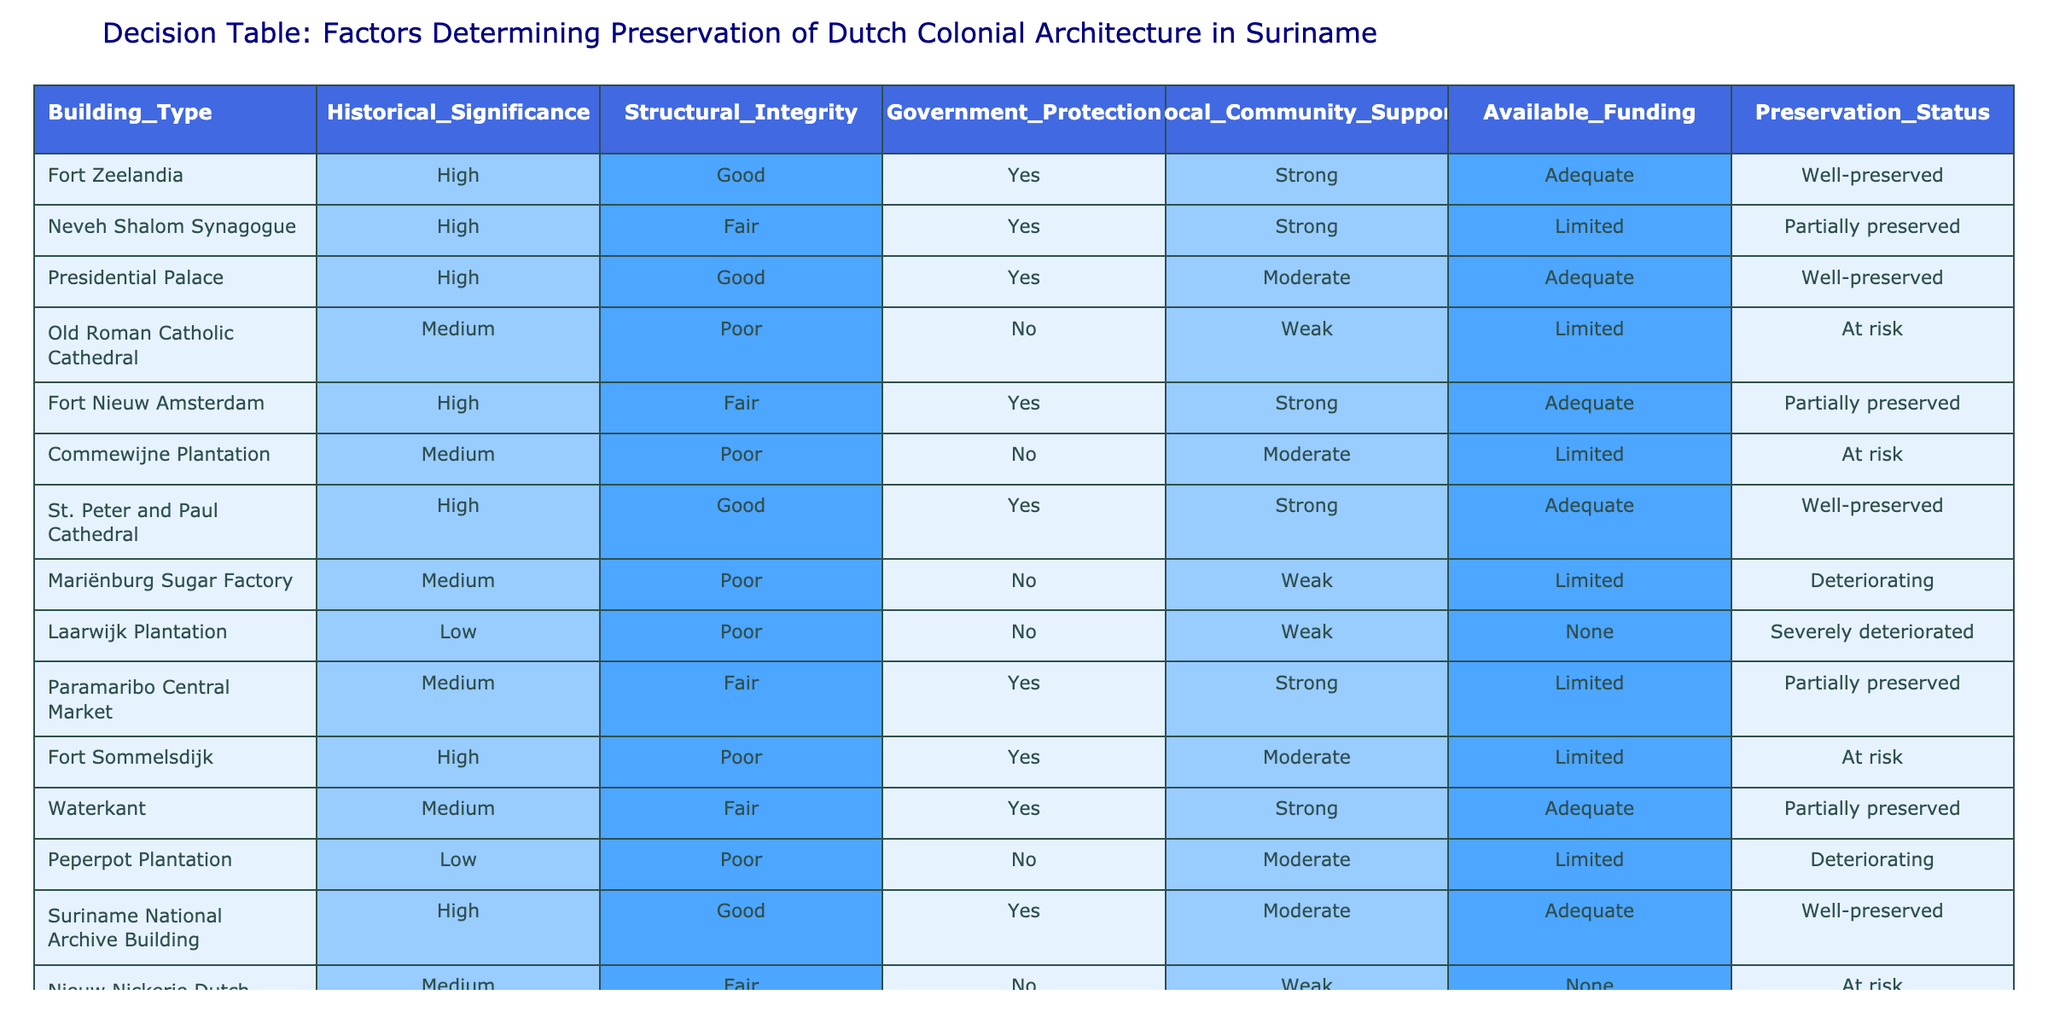What is the preservation status of Fort Zeelandia? The table lists Fort Zeelandia under the "Preservation_Status" column, which shows it is categorized as "Well-preserved."
Answer: Well-preserved How many buildings have government protection? In the table, we look for the "Government_Protection" column where the value is "Yes." Counting the rows with this value, we find there are six buildings with government protection: Fort Zeelandia, Neveh Shalom Synagogue, Presidential Palace, Fort Nieuw Amsterdam, St. Peter and Paul Cathedral, and Suriname National Archive Building.
Answer: 6 What is the average historical significance rating of all buildings listed? The ratings for historical significance are categorized as High, Medium, and Low. Evaluating the table, we count that there are 6 buildings rated High, 5 rated Medium, and 3 rated Low. To compute the average on a scale of 1 to 3 (where High = 3, Medium = 2, Low = 1), we calculate: (6*3 + 5*2 + 3*1) / (6 + 5 + 3) = (18 + 10 + 3) / 14 = 31 / 14 = 2.21. Rounding gives an average significance of 2.2.
Answer: 2.2 Does the Mariënburg Sugar Factory have local community support? Referring to the "Local_Community_Support" column for the Mariënburg Sugar Factory shows "Weak." Therefore, it does not have strong local community backing.
Answer: No What is the total number of buildings at risk of deterioration? We examine the "Preservation_Status" column for the term "At risk." The buildings at risk include the Old Roman Catholic Cathedral, Commewijne Plantation, Fort Sommelsdijk, and Nieuw Nickerie Dutch Reformed Church, totaling four buildings.
Answer: 4 Which building with high historical significance is currently rated at risk? We look into buildings with "High" under "Historical_Significance" and check their "Preservation_Status." Fort Sommelsdijk is the only one categorized as "At risk," making it the answer.
Answer: Fort Sommelsdijk What can we infer about the relationship between available funding and preservation status? To analyze this, we review the "Available_Funding" of each building. Those with limited or none funding tend to have worsening preservation statuses like "At risk", "Deteriorating" or "Severely deteriorated". This suggests a negative correlation between available funding and preservation status.
Answer: Negative correlation Which building is both well-preserved and has strong local community support? From the table, we identify the buildings marked "Well-preserved" and check for "Strong" in the "Local_Community_Support." The St. Peter and Paul Cathedral meets both criteria.
Answer: St. Peter and Paul Cathedral 